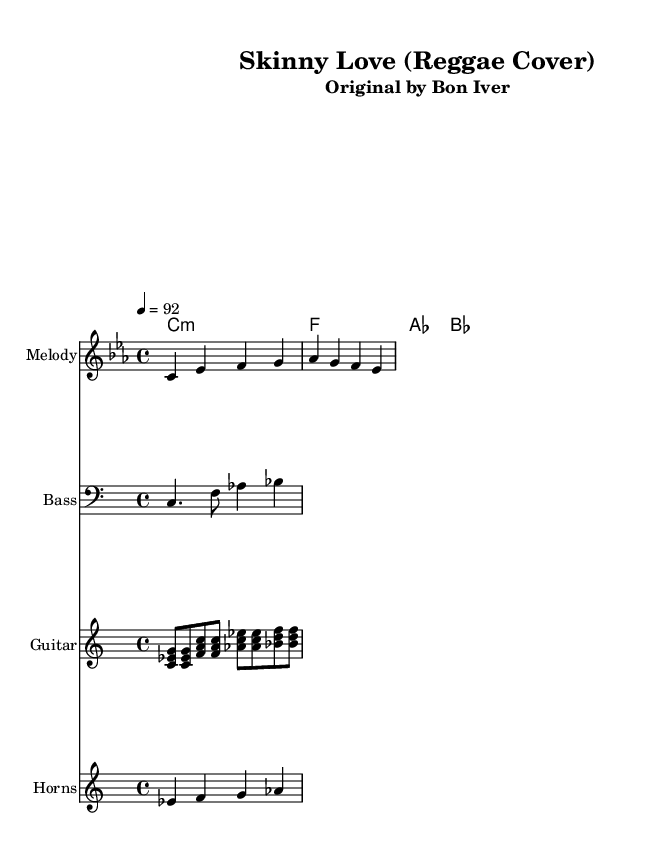What is the key signature of this music? The key signature is C minor, which has three flats (B flat, E flat, and A flat). This can be identified by the key signature indicated at the beginning of the sheet music.
Answer: C minor What is the time signature? The time signature is 4/4, which is indicated just after the key signature. This means there are four beats in each measure, and each beat is a quarter note.
Answer: 4/4 What is the tempo marking? The tempo marking is quarter note equals 92, indicating the speed at which the piece is to be played. It is located at the start of the score, typically above the staff.
Answer: 92 How many measures are in the melody section? The melody section contains two measures, which can be counted by examining the bar lines separating the notes. Each set of notes between the bar lines represents one measure.
Answer: 2 What type of influence does this cover reflect? The influence is from reggae, specifically noted by the reggae style in the guitar skank pattern and the presence of bass lines that are characteristic of this genre. This can be inferred from the title and the arrangement style.
Answer: Reggae Which instruments are included in this arrangement? The arrangement includes melody, bass, guitar, and horns as indicated by the labeled staves in the score. Each instrument's part is separately notated for clarity.
Answer: Melody, bass, guitar, horns What chord progression is used in this piece? The chord progression follows a pattern of C minor, F, A flat, and B flat as indicated by the chord names notated above the melody. This sequence can be identified from the chord names provided in the score.
Answer: C minor, F, A flat, B flat 